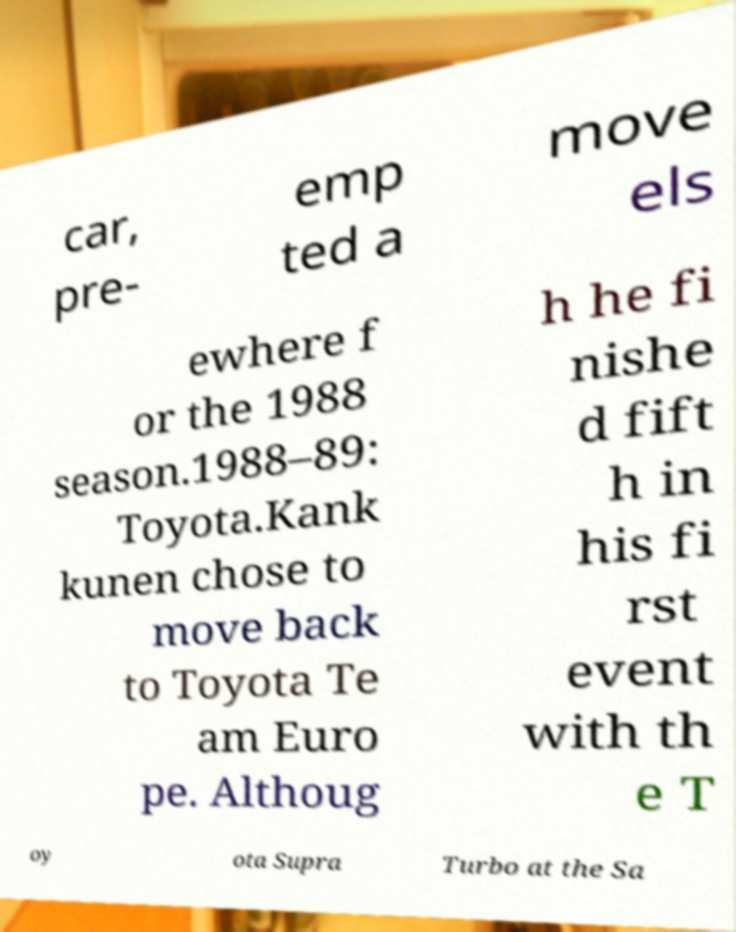Could you assist in decoding the text presented in this image and type it out clearly? car, pre- emp ted a move els ewhere f or the 1988 season.1988–89: Toyota.Kank kunen chose to move back to Toyota Te am Euro pe. Althoug h he fi nishe d fift h in his fi rst event with th e T oy ota Supra Turbo at the Sa 